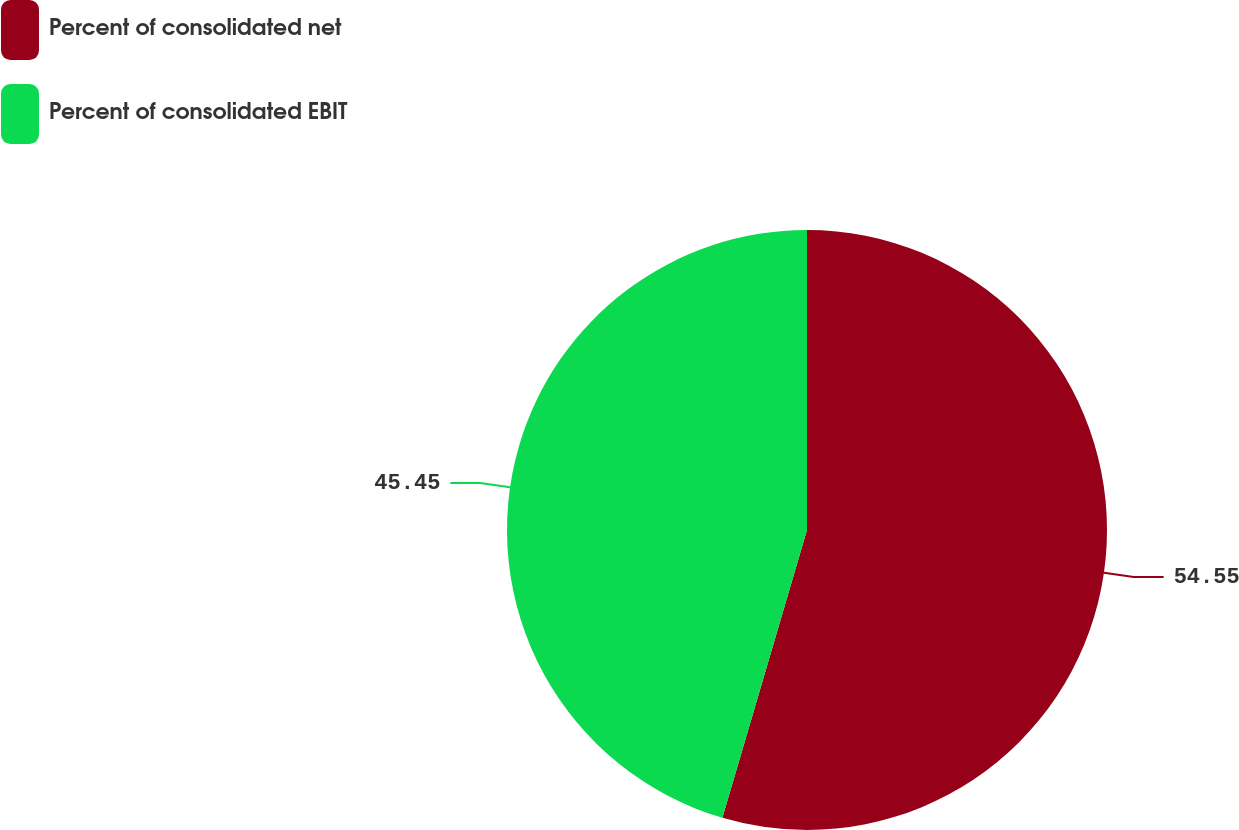Convert chart to OTSL. <chart><loc_0><loc_0><loc_500><loc_500><pie_chart><fcel>Percent of consolidated net<fcel>Percent of consolidated EBIT<nl><fcel>54.55%<fcel>45.45%<nl></chart> 